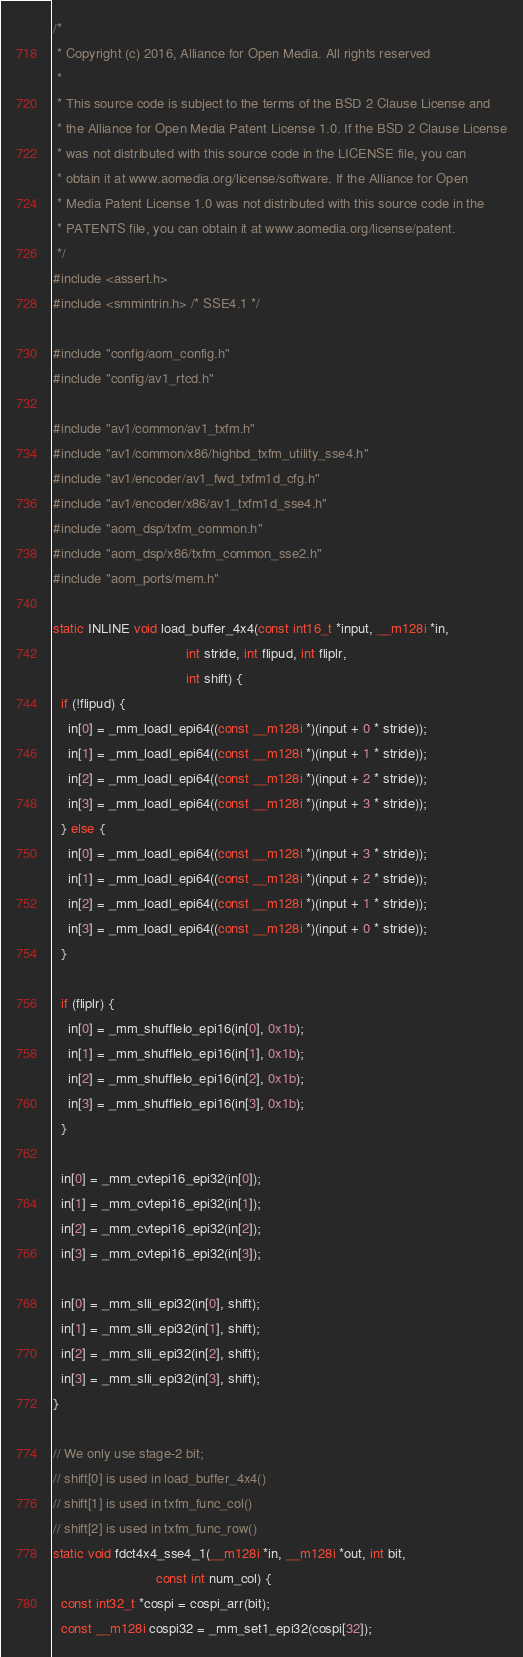Convert code to text. <code><loc_0><loc_0><loc_500><loc_500><_C_>/*
 * Copyright (c) 2016, Alliance for Open Media. All rights reserved
 *
 * This source code is subject to the terms of the BSD 2 Clause License and
 * the Alliance for Open Media Patent License 1.0. If the BSD 2 Clause License
 * was not distributed with this source code in the LICENSE file, you can
 * obtain it at www.aomedia.org/license/software. If the Alliance for Open
 * Media Patent License 1.0 was not distributed with this source code in the
 * PATENTS file, you can obtain it at www.aomedia.org/license/patent.
 */
#include <assert.h>
#include <smmintrin.h> /* SSE4.1 */

#include "config/aom_config.h"
#include "config/av1_rtcd.h"

#include "av1/common/av1_txfm.h"
#include "av1/common/x86/highbd_txfm_utility_sse4.h"
#include "av1/encoder/av1_fwd_txfm1d_cfg.h"
#include "av1/encoder/x86/av1_txfm1d_sse4.h"
#include "aom_dsp/txfm_common.h"
#include "aom_dsp/x86/txfm_common_sse2.h"
#include "aom_ports/mem.h"

static INLINE void load_buffer_4x4(const int16_t *input, __m128i *in,
                                   int stride, int flipud, int fliplr,
                                   int shift) {
  if (!flipud) {
    in[0] = _mm_loadl_epi64((const __m128i *)(input + 0 * stride));
    in[1] = _mm_loadl_epi64((const __m128i *)(input + 1 * stride));
    in[2] = _mm_loadl_epi64((const __m128i *)(input + 2 * stride));
    in[3] = _mm_loadl_epi64((const __m128i *)(input + 3 * stride));
  } else {
    in[0] = _mm_loadl_epi64((const __m128i *)(input + 3 * stride));
    in[1] = _mm_loadl_epi64((const __m128i *)(input + 2 * stride));
    in[2] = _mm_loadl_epi64((const __m128i *)(input + 1 * stride));
    in[3] = _mm_loadl_epi64((const __m128i *)(input + 0 * stride));
  }

  if (fliplr) {
    in[0] = _mm_shufflelo_epi16(in[0], 0x1b);
    in[1] = _mm_shufflelo_epi16(in[1], 0x1b);
    in[2] = _mm_shufflelo_epi16(in[2], 0x1b);
    in[3] = _mm_shufflelo_epi16(in[3], 0x1b);
  }

  in[0] = _mm_cvtepi16_epi32(in[0]);
  in[1] = _mm_cvtepi16_epi32(in[1]);
  in[2] = _mm_cvtepi16_epi32(in[2]);
  in[3] = _mm_cvtepi16_epi32(in[3]);

  in[0] = _mm_slli_epi32(in[0], shift);
  in[1] = _mm_slli_epi32(in[1], shift);
  in[2] = _mm_slli_epi32(in[2], shift);
  in[3] = _mm_slli_epi32(in[3], shift);
}

// We only use stage-2 bit;
// shift[0] is used in load_buffer_4x4()
// shift[1] is used in txfm_func_col()
// shift[2] is used in txfm_func_row()
static void fdct4x4_sse4_1(__m128i *in, __m128i *out, int bit,
                           const int num_col) {
  const int32_t *cospi = cospi_arr(bit);
  const __m128i cospi32 = _mm_set1_epi32(cospi[32]);</code> 